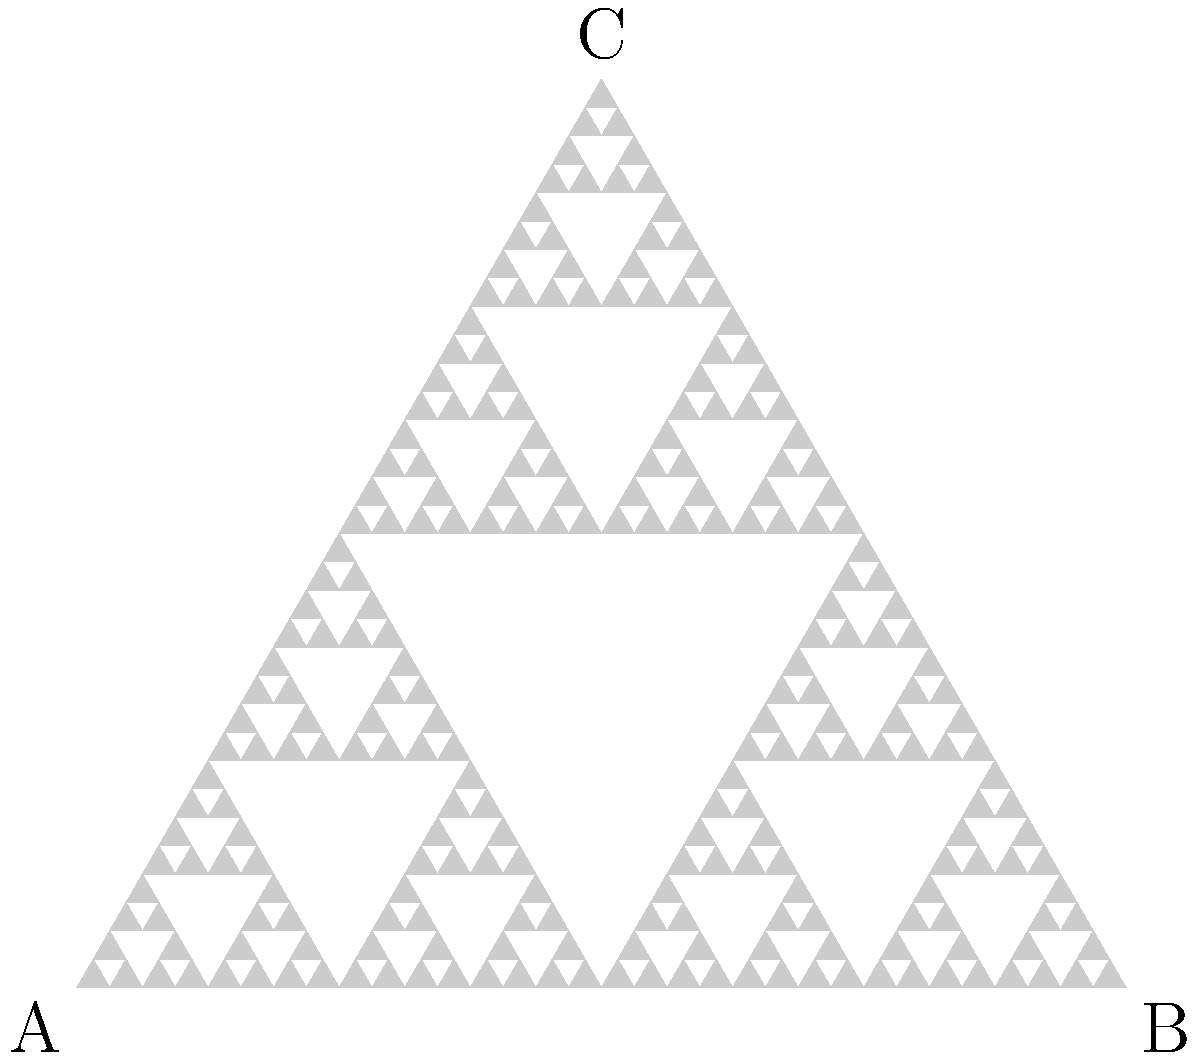In the context of using fractals to represent patterns in ancient textiles and artwork, consider the Sierpinski triangle shown above. If we continue this fractal pattern indefinitely, what is the fractal dimension of the resulting shape? Express your answer as a fraction. To find the fractal dimension of the Sierpinski triangle, we can use the following steps:

1) The fractal dimension (D) is given by the formula:
   $$D = \frac{\log N}{\log S}$$
   where N is the number of self-similar pieces, and S is the scaling factor.

2) For the Sierpinski triangle:
   - Each iteration creates 3 smaller triangles (N = 3)
   - Each smaller triangle has sides that are 1/2 the length of the original (S = 2)

3) Plugging these values into the formula:
   $$D = \frac{\log 3}{\log 2}$$

4) This can be simplified to:
   $$D = \frac{\log_2 3}{1} = \log_2 3$$

5) The value of $\log_2 3$ is approximately 1.585, which can be expressed as the fraction:
   $$\frac{\log 3}{\log 2}$$

This fractal dimension indicates that the Sierpinski triangle has a dimension between a 1-dimensional line (D = 1) and a 2-dimensional plane (D = 2), reflecting its intricate, self-similar structure that fills more space than a line but less than a solid triangle.
Answer: $\frac{\log 3}{\log 2}$ 